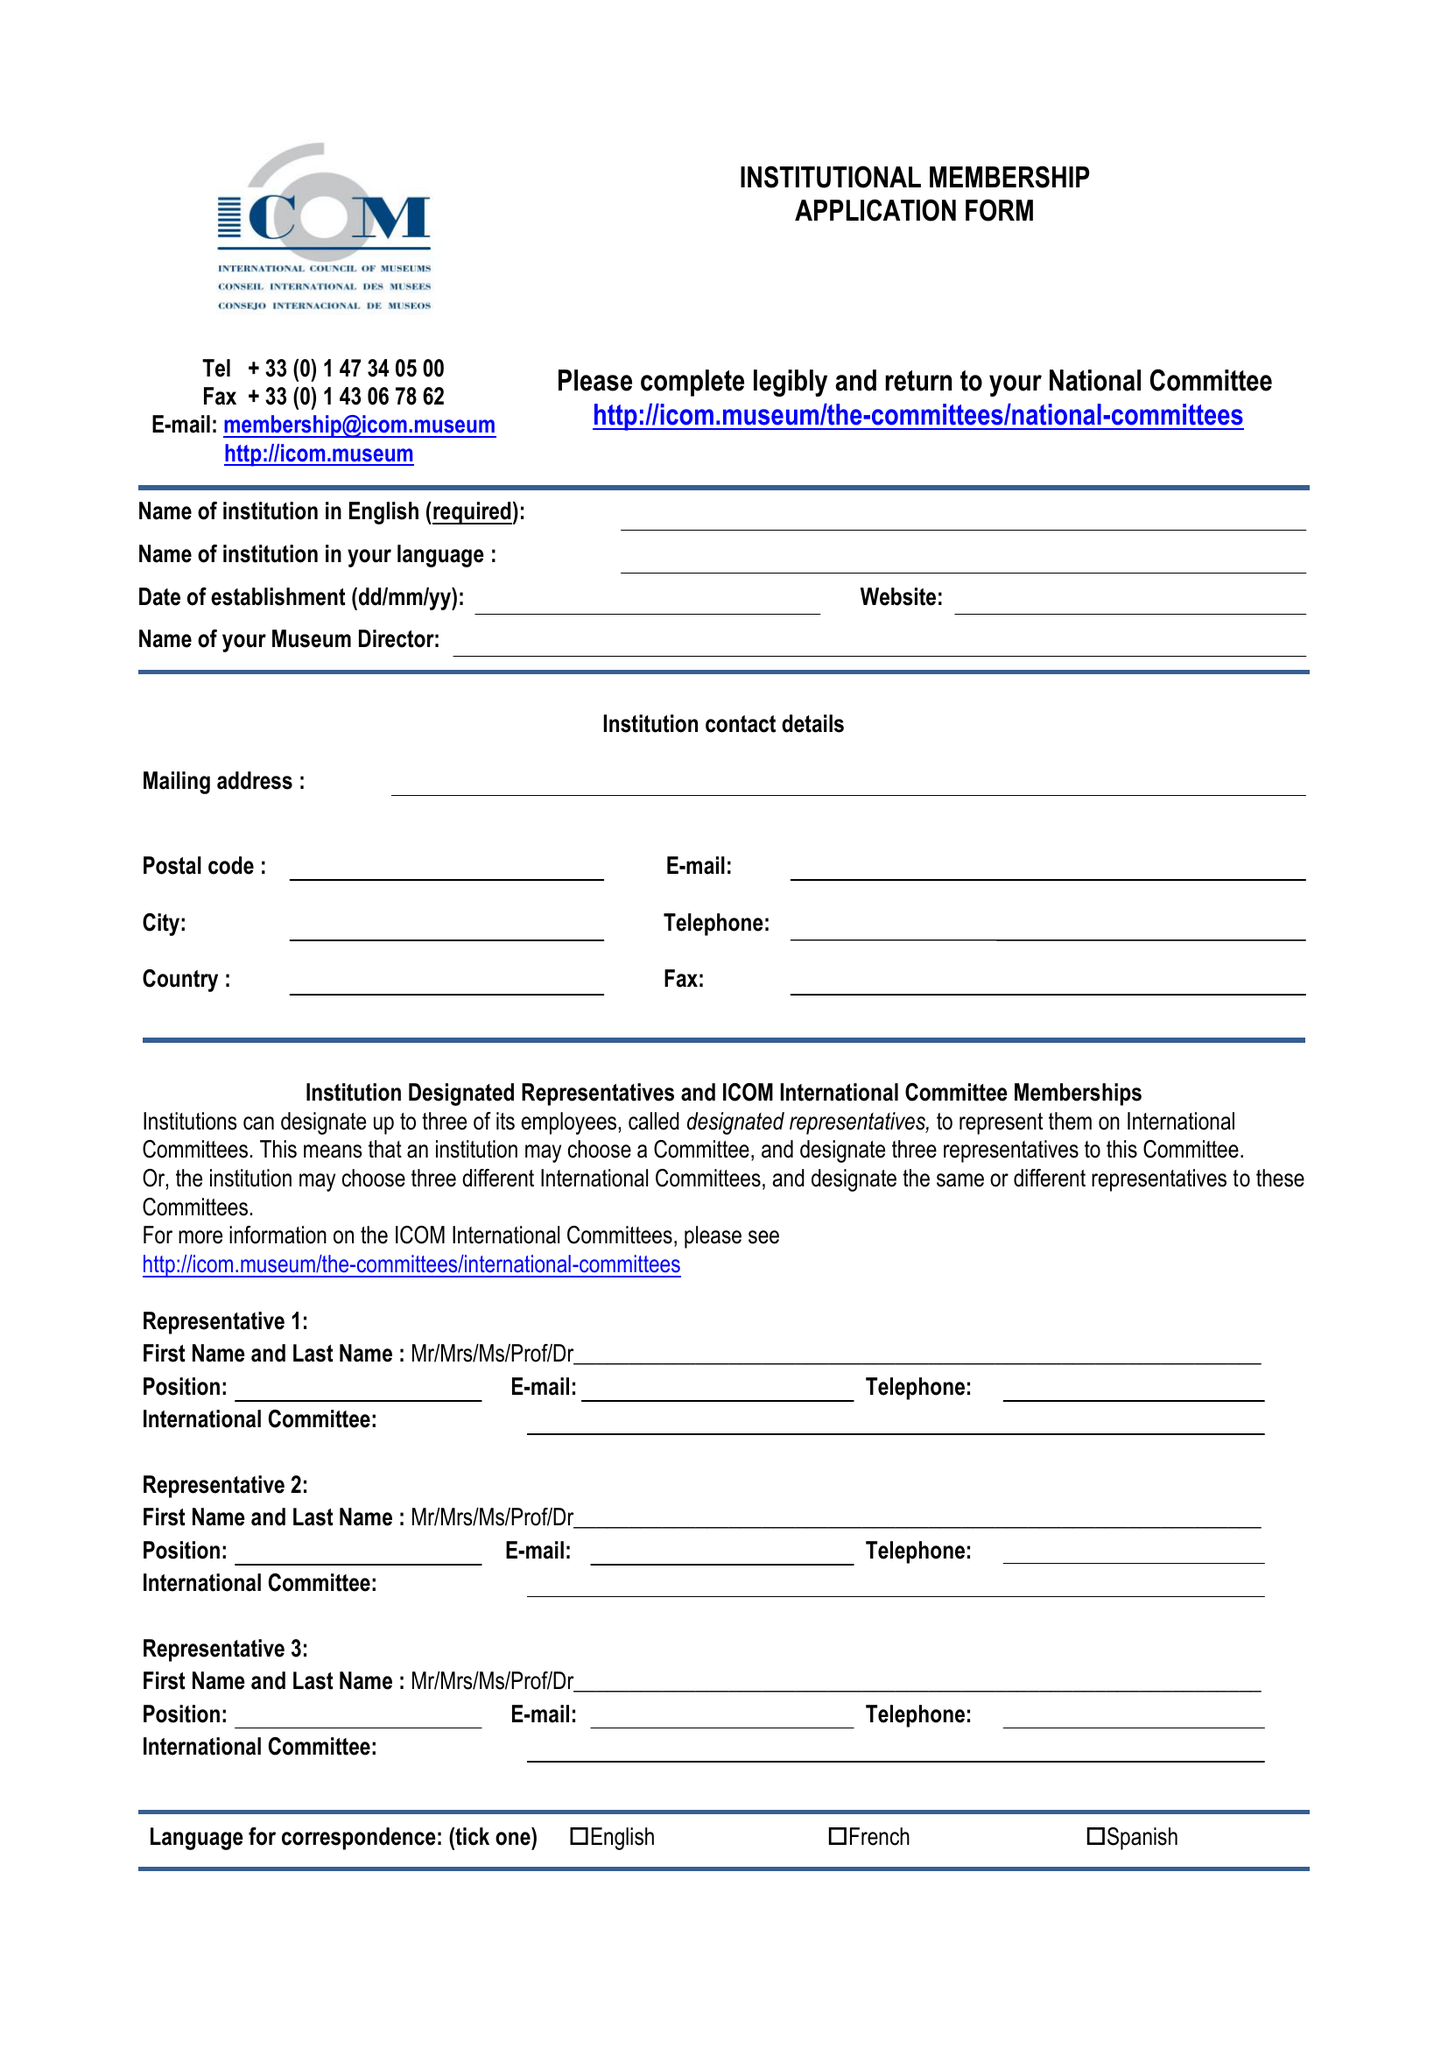What is the value for the charity_name?
Answer the question using a single word or phrase. International Council Of Museums (United Kingdom) 